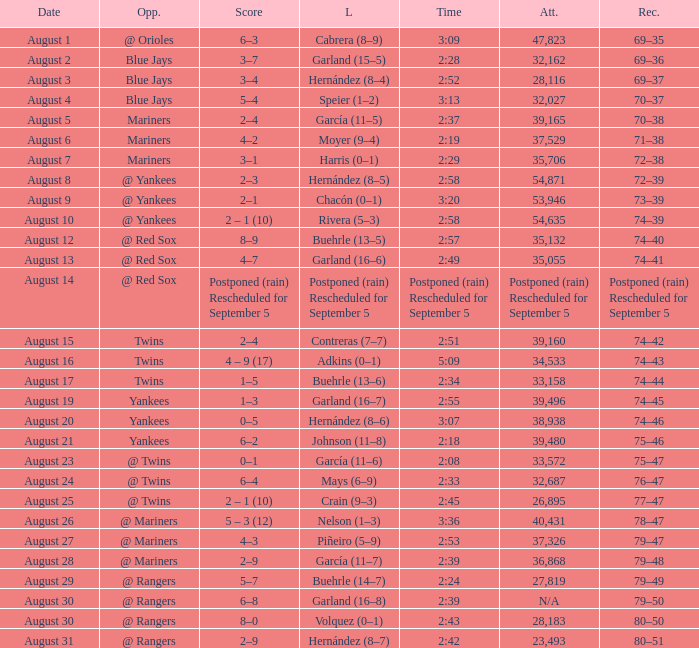Who finished the race at 2:42 but didn't secure a victory? Hernández (8–7). 